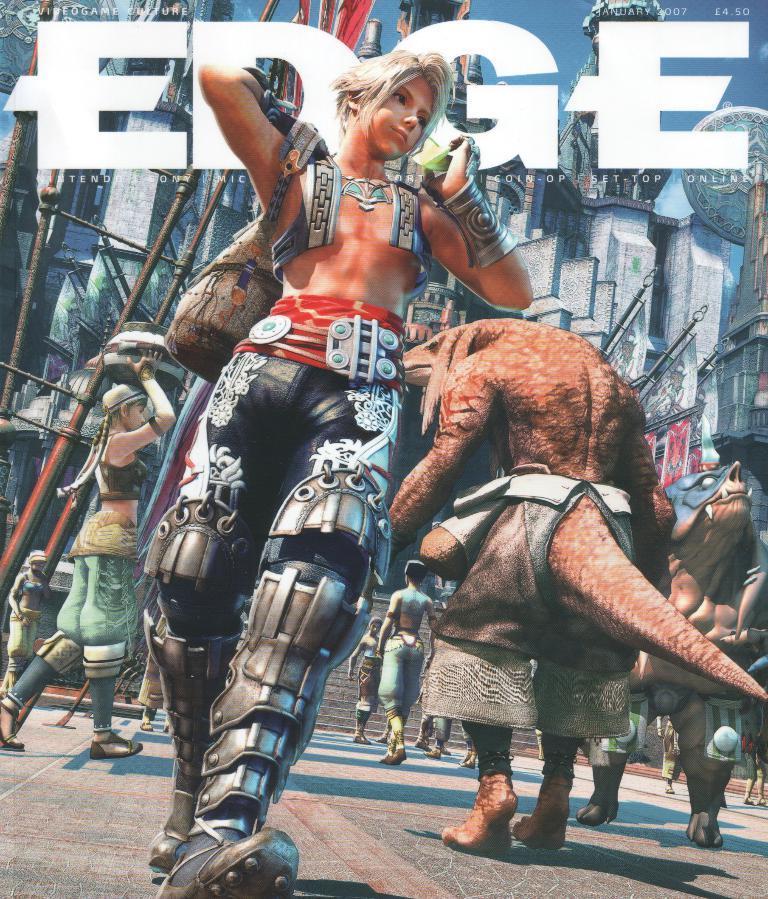How would you summarize this image in a sentence or two? In this image I can see the animated picture in which I can see a person wearing black, white and grey colored dress is standing. In the background I can see few monsters, few persons, few stairs , few buildings and the sky. 